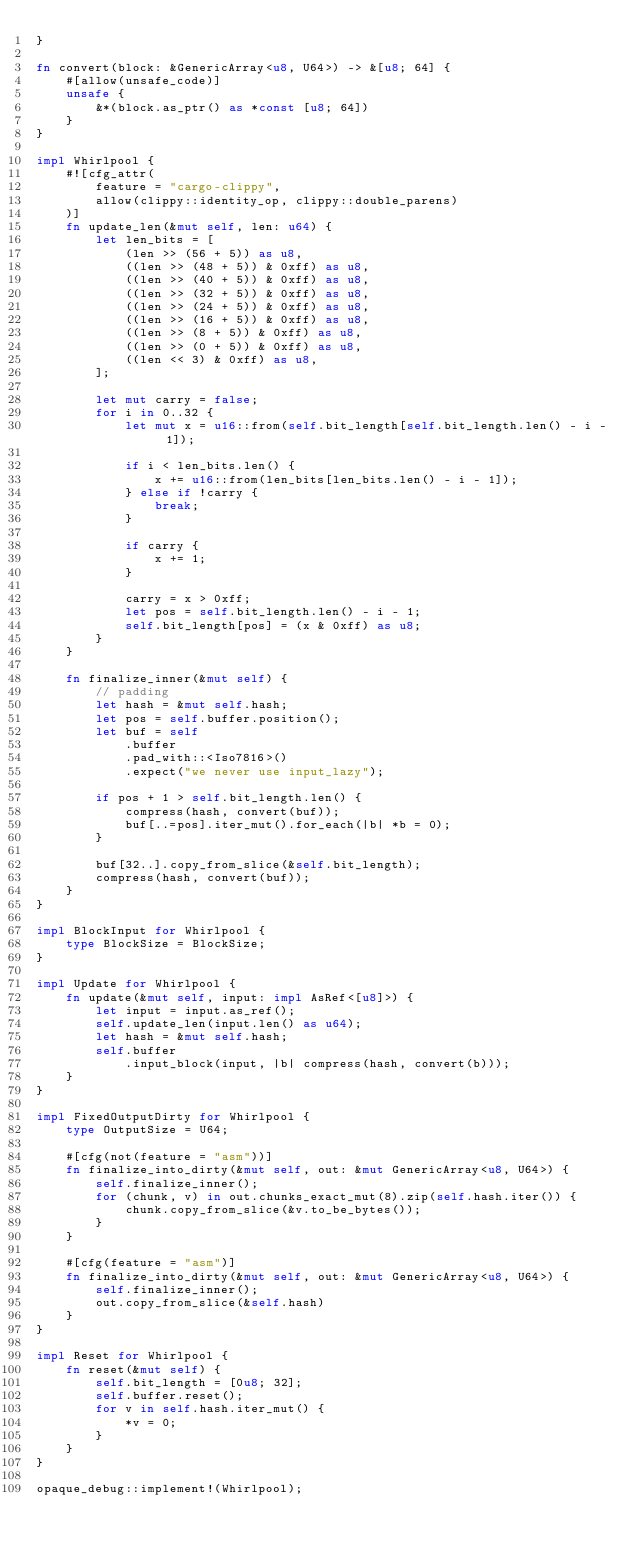<code> <loc_0><loc_0><loc_500><loc_500><_Rust_>}

fn convert(block: &GenericArray<u8, U64>) -> &[u8; 64] {
    #[allow(unsafe_code)]
    unsafe {
        &*(block.as_ptr() as *const [u8; 64])
    }
}

impl Whirlpool {
    #![cfg_attr(
        feature = "cargo-clippy",
        allow(clippy::identity_op, clippy::double_parens)
    )]
    fn update_len(&mut self, len: u64) {
        let len_bits = [
            (len >> (56 + 5)) as u8,
            ((len >> (48 + 5)) & 0xff) as u8,
            ((len >> (40 + 5)) & 0xff) as u8,
            ((len >> (32 + 5)) & 0xff) as u8,
            ((len >> (24 + 5)) & 0xff) as u8,
            ((len >> (16 + 5)) & 0xff) as u8,
            ((len >> (8 + 5)) & 0xff) as u8,
            ((len >> (0 + 5)) & 0xff) as u8,
            ((len << 3) & 0xff) as u8,
        ];

        let mut carry = false;
        for i in 0..32 {
            let mut x = u16::from(self.bit_length[self.bit_length.len() - i - 1]);

            if i < len_bits.len() {
                x += u16::from(len_bits[len_bits.len() - i - 1]);
            } else if !carry {
                break;
            }

            if carry {
                x += 1;
            }

            carry = x > 0xff;
            let pos = self.bit_length.len() - i - 1;
            self.bit_length[pos] = (x & 0xff) as u8;
        }
    }

    fn finalize_inner(&mut self) {
        // padding
        let hash = &mut self.hash;
        let pos = self.buffer.position();
        let buf = self
            .buffer
            .pad_with::<Iso7816>()
            .expect("we never use input_lazy");

        if pos + 1 > self.bit_length.len() {
            compress(hash, convert(buf));
            buf[..=pos].iter_mut().for_each(|b| *b = 0);
        }

        buf[32..].copy_from_slice(&self.bit_length);
        compress(hash, convert(buf));
    }
}

impl BlockInput for Whirlpool {
    type BlockSize = BlockSize;
}

impl Update for Whirlpool {
    fn update(&mut self, input: impl AsRef<[u8]>) {
        let input = input.as_ref();
        self.update_len(input.len() as u64);
        let hash = &mut self.hash;
        self.buffer
            .input_block(input, |b| compress(hash, convert(b)));
    }
}

impl FixedOutputDirty for Whirlpool {
    type OutputSize = U64;

    #[cfg(not(feature = "asm"))]
    fn finalize_into_dirty(&mut self, out: &mut GenericArray<u8, U64>) {
        self.finalize_inner();
        for (chunk, v) in out.chunks_exact_mut(8).zip(self.hash.iter()) {
            chunk.copy_from_slice(&v.to_be_bytes());
        }
    }

    #[cfg(feature = "asm")]
    fn finalize_into_dirty(&mut self, out: &mut GenericArray<u8, U64>) {
        self.finalize_inner();
        out.copy_from_slice(&self.hash)
    }
}

impl Reset for Whirlpool {
    fn reset(&mut self) {
        self.bit_length = [0u8; 32];
        self.buffer.reset();
        for v in self.hash.iter_mut() {
            *v = 0;
        }
    }
}

opaque_debug::implement!(Whirlpool);</code> 